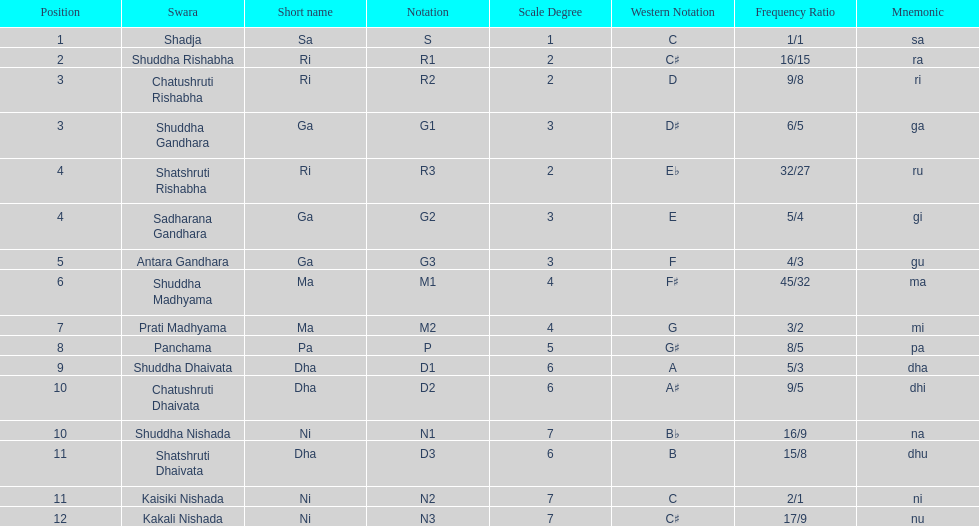Which swara holds the last position? Kakali Nishada. 